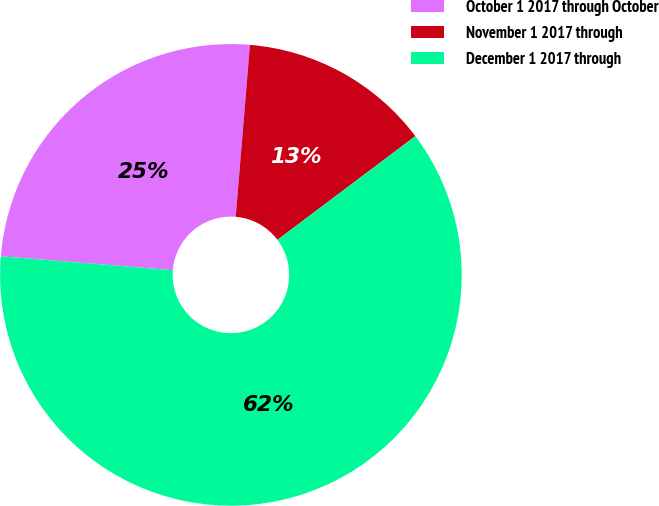Convert chart to OTSL. <chart><loc_0><loc_0><loc_500><loc_500><pie_chart><fcel>October 1 2017 through October<fcel>November 1 2017 through<fcel>December 1 2017 through<nl><fcel>25.03%<fcel>13.42%<fcel>61.55%<nl></chart> 